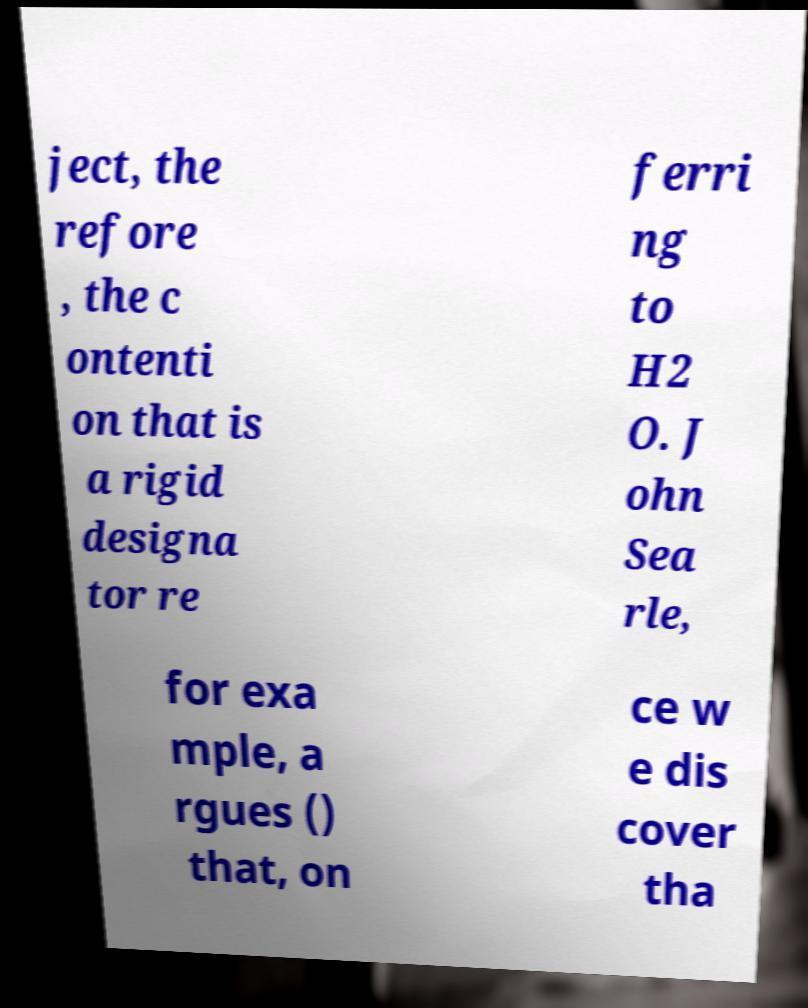Please read and relay the text visible in this image. What does it say? ject, the refore , the c ontenti on that is a rigid designa tor re ferri ng to H2 O. J ohn Sea rle, for exa mple, a rgues () that, on ce w e dis cover tha 